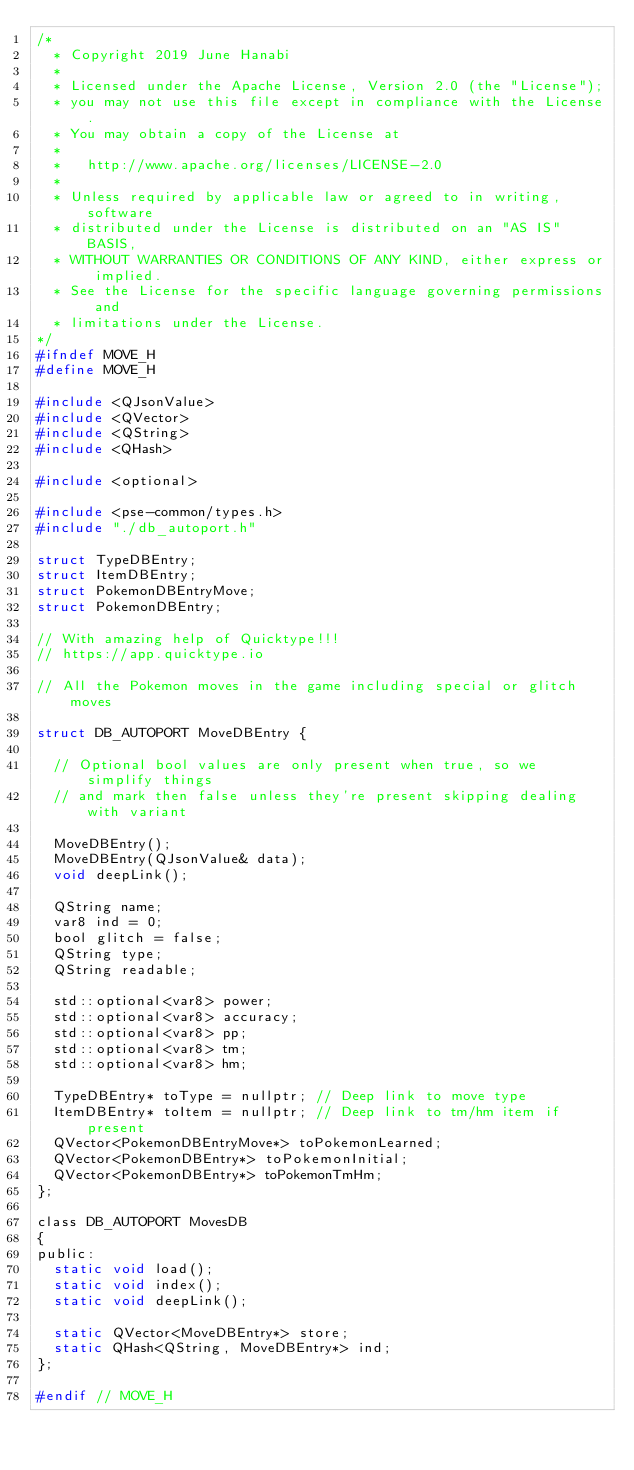Convert code to text. <code><loc_0><loc_0><loc_500><loc_500><_C_>/*
  * Copyright 2019 June Hanabi
  *
  * Licensed under the Apache License, Version 2.0 (the "License");
  * you may not use this file except in compliance with the License.
  * You may obtain a copy of the License at
  *
  *   http://www.apache.org/licenses/LICENSE-2.0
  *
  * Unless required by applicable law or agreed to in writing, software
  * distributed under the License is distributed on an "AS IS" BASIS,
  * WITHOUT WARRANTIES OR CONDITIONS OF ANY KIND, either express or implied.
  * See the License for the specific language governing permissions and
  * limitations under the License.
*/
#ifndef MOVE_H
#define MOVE_H

#include <QJsonValue>
#include <QVector>
#include <QString>
#include <QHash>

#include <optional>

#include <pse-common/types.h>
#include "./db_autoport.h"

struct TypeDBEntry;
struct ItemDBEntry;
struct PokemonDBEntryMove;
struct PokemonDBEntry;

// With amazing help of Quicktype!!!
// https://app.quicktype.io

// All the Pokemon moves in the game including special or glitch moves

struct DB_AUTOPORT MoveDBEntry {

  // Optional bool values are only present when true, so we simplify things
  // and mark then false unless they're present skipping dealing with variant

  MoveDBEntry();
  MoveDBEntry(QJsonValue& data);
  void deepLink();

  QString name;
  var8 ind = 0;
  bool glitch = false;
  QString type;
  QString readable;

  std::optional<var8> power;
  std::optional<var8> accuracy;
  std::optional<var8> pp;
  std::optional<var8> tm;
  std::optional<var8> hm;

  TypeDBEntry* toType = nullptr; // Deep link to move type
  ItemDBEntry* toItem = nullptr; // Deep link to tm/hm item if present
  QVector<PokemonDBEntryMove*> toPokemonLearned;
  QVector<PokemonDBEntry*> toPokemonInitial;
  QVector<PokemonDBEntry*> toPokemonTmHm;
};

class DB_AUTOPORT MovesDB
{
public:
  static void load();
  static void index();
  static void deepLink();

  static QVector<MoveDBEntry*> store;
  static QHash<QString, MoveDBEntry*> ind;
};

#endif // MOVE_H
</code> 